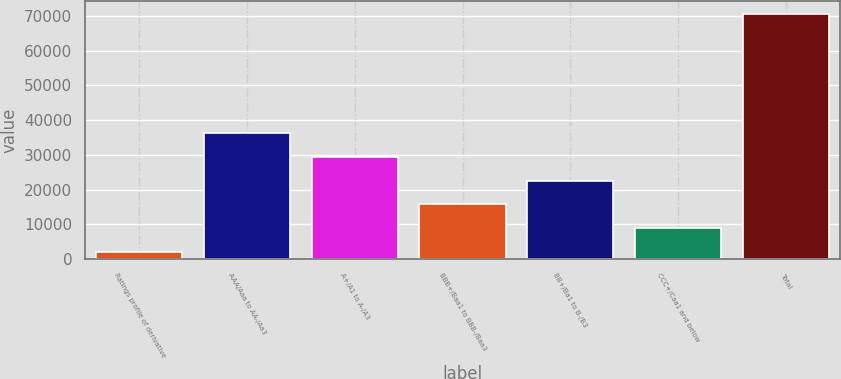Convert chart to OTSL. <chart><loc_0><loc_0><loc_500><loc_500><bar_chart><fcel>Ratings profile of derivative<fcel>AAA/Aaa to AA-/Aa3<fcel>A+/A1 to A-/A3<fcel>BBB+/Baa1 to BBB-/Baa3<fcel>BB+/Ba1 to B-/B3<fcel>CCC+/Caa1 and below<fcel>Total<nl><fcel>2011<fcel>36340.5<fcel>29474.6<fcel>15742.8<fcel>22608.7<fcel>8876.9<fcel>70670<nl></chart> 